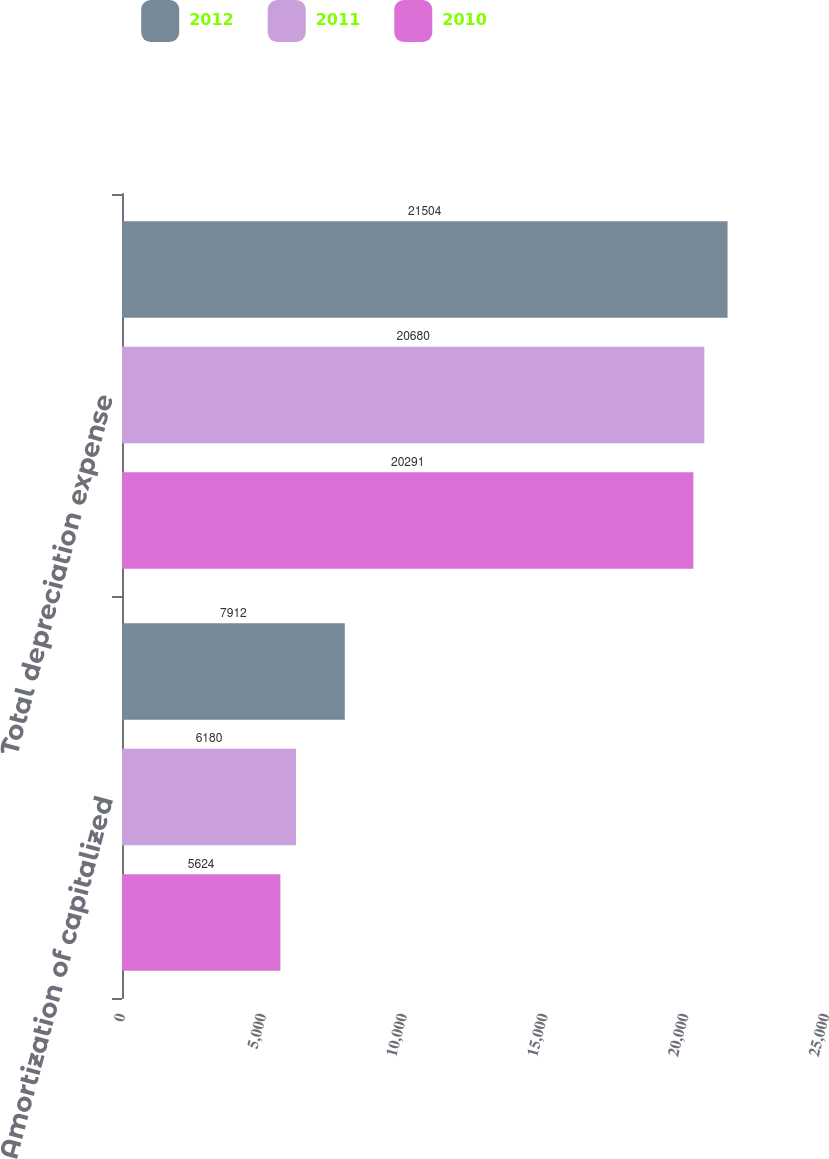Convert chart to OTSL. <chart><loc_0><loc_0><loc_500><loc_500><stacked_bar_chart><ecel><fcel>Amortization of capitalized<fcel>Total depreciation expense<nl><fcel>2012<fcel>7912<fcel>21504<nl><fcel>2011<fcel>6180<fcel>20680<nl><fcel>2010<fcel>5624<fcel>20291<nl></chart> 